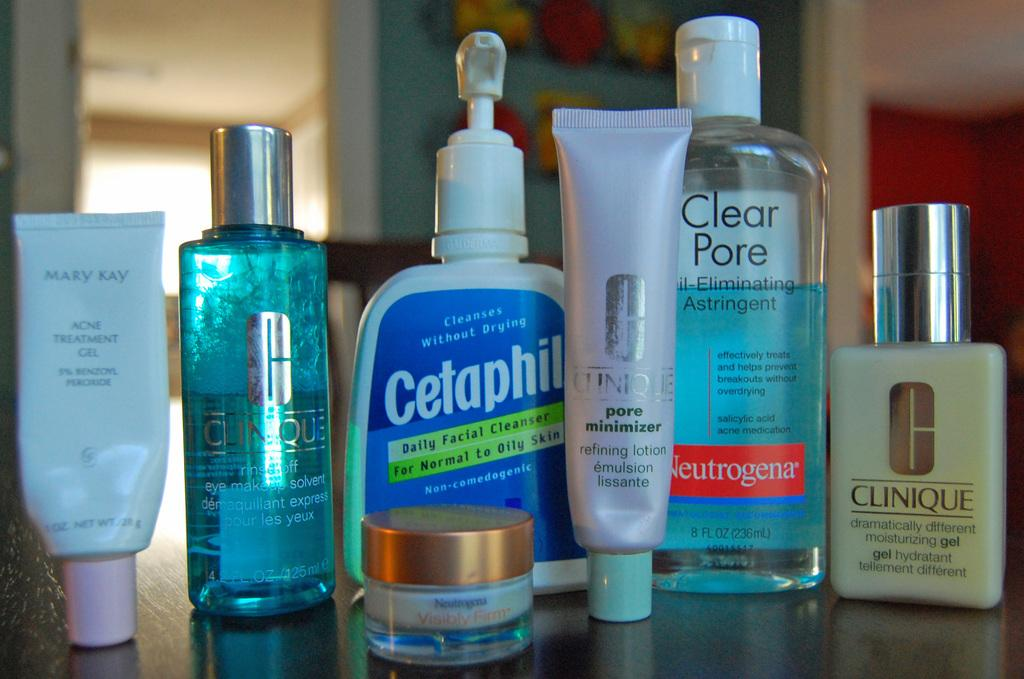Provide a one-sentence caption for the provided image. A collection of toiletry products including Cetaphil and Clear Pore. 